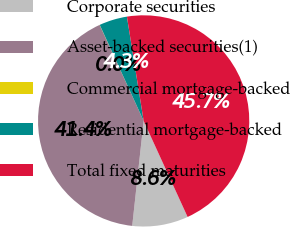Convert chart to OTSL. <chart><loc_0><loc_0><loc_500><loc_500><pie_chart><fcel>Corporate securities<fcel>Asset-backed securities(1)<fcel>Commercial mortgage-backed<fcel>Residential mortgage-backed<fcel>Total fixed maturities<nl><fcel>8.56%<fcel>41.43%<fcel>0.02%<fcel>4.29%<fcel>45.7%<nl></chart> 